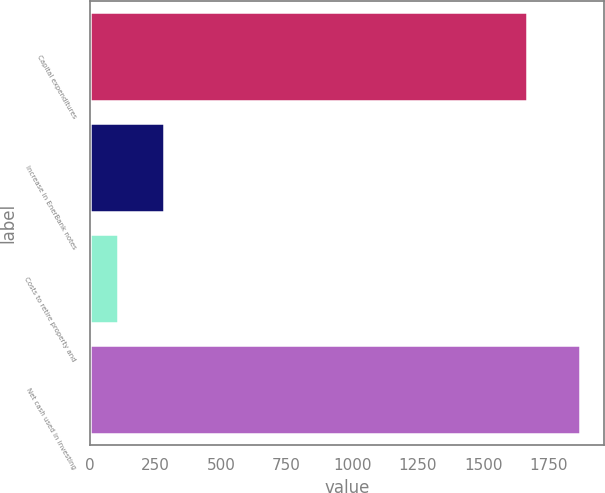Convert chart. <chart><loc_0><loc_0><loc_500><loc_500><bar_chart><fcel>Capital expenditures<fcel>Increase in EnerBank notes<fcel>Costs to retire property and<fcel>Net cash used in investing<nl><fcel>1665<fcel>284<fcel>108<fcel>1868<nl></chart> 